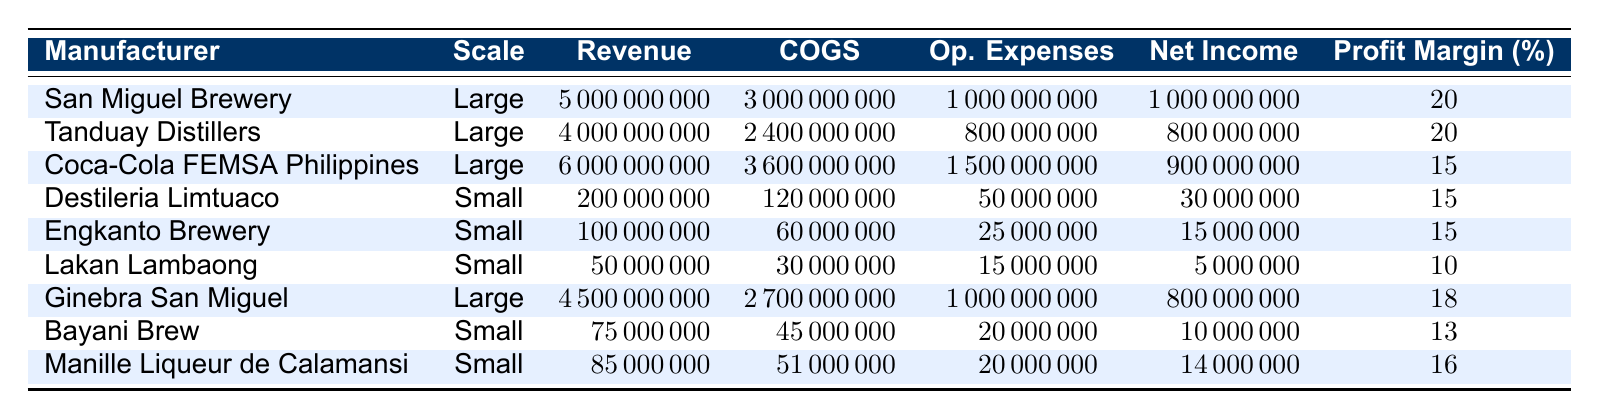What is the profit margin for San Miguel Brewery? Looking at the table, San Miguel Brewery's profit margin is listed directly in the Profit Margin column. It shows 20%.
Answer: 20% Which manufacturer has the highest net income? By examining the Net Income column, San Miguel Brewery has a net income of 1,000,000,000, which is higher than any other manufacturer listed.
Answer: San Miguel Brewery What is the average profit margin of large-scale manufacturers? The profit margins for large-scale manufacturers are 20%, 20%, 15%, and 18%. To find the average, sum these values: (20 + 20 + 15 + 18) = 73. Then, divide by the number of large-scale manufacturers (4): 73/4 = 18.25.
Answer: 18.25 Is the profit margin of Lakan Lambaong higher than 15%? Lakan Lambaong's profit margin is listed as 10%. Therefore, 10% is less than 15%, making this statement false.
Answer: No What is the total revenue for small-scale manufacturers combined? The small-scale manufacturers listed are Destileria Limtuaco (200000000), Engkanto Brewery (100000000), Lakan Lambaong (50000000), Bayani Brew (75000000), and Manille Liqueur de Calamansi (85000000). Summing these up: 200000000 + 100000000 + 50000000 + 75000000 + 85000000 = 510000000.
Answer: 510000000 Which manufacturer has a profit margin of 16% or less? Reviewing the Profit Margin column, the manufacturers with 16% or lower are Lakan Lambaong (10%), Bayani Brew (13%), and Destileria Limtuaco (15%), as well as Engkanto Brewery (15%) and Manille Liqueur de Calamansi (16%).
Answer: Lakan Lambaong, Bayani Brew, Destileria Limtuaco, Engkanto Brewery, Manille Liqueur de Calamansi What is the difference in net income between Coca-Cola FEMSA Philippines and Ginebra San Miguel? Coca-Cola FEMSA Philippines has a net income of 900000000 and Ginebra San Miguel has a net income of 800000000. The difference is 900000000 - 800000000 = 100000000.
Answer: 100000000 Are there more small-scale manufacturers than large-scale manufacturers? There are 5 small-scale manufacturers (Destileria Limtuaco, Engkanto Brewery, Lakan Lambaong, Bayani Brew, Manille Liqueur de Calamansi) and 4 large-scale manufacturers (San Miguel Brewery, Tanduay Distillers, Coca-Cola FEMSA Philippines, Ginebra San Miguel). Therefore, there are more small-scale manufacturers.
Answer: Yes 